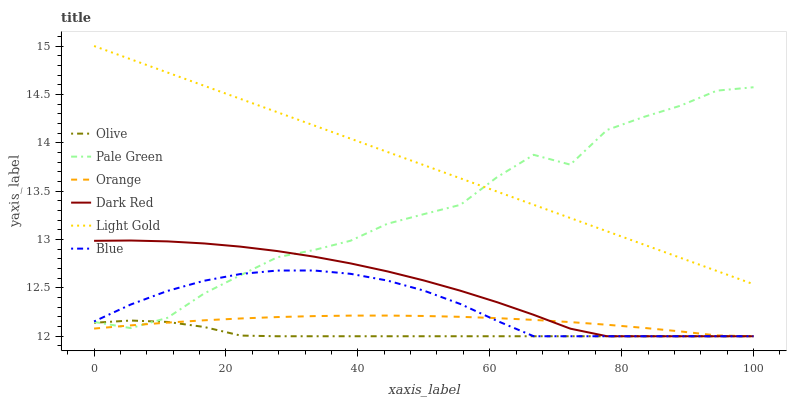Does Olive have the minimum area under the curve?
Answer yes or no. Yes. Does Light Gold have the maximum area under the curve?
Answer yes or no. Yes. Does Dark Red have the minimum area under the curve?
Answer yes or no. No. Does Dark Red have the maximum area under the curve?
Answer yes or no. No. Is Light Gold the smoothest?
Answer yes or no. Yes. Is Pale Green the roughest?
Answer yes or no. Yes. Is Dark Red the smoothest?
Answer yes or no. No. Is Dark Red the roughest?
Answer yes or no. No. Does Pale Green have the lowest value?
Answer yes or no. No. Does Light Gold have the highest value?
Answer yes or no. Yes. Does Dark Red have the highest value?
Answer yes or no. No. Is Blue less than Light Gold?
Answer yes or no. Yes. Is Light Gold greater than Olive?
Answer yes or no. Yes. Does Blue intersect Light Gold?
Answer yes or no. No. 